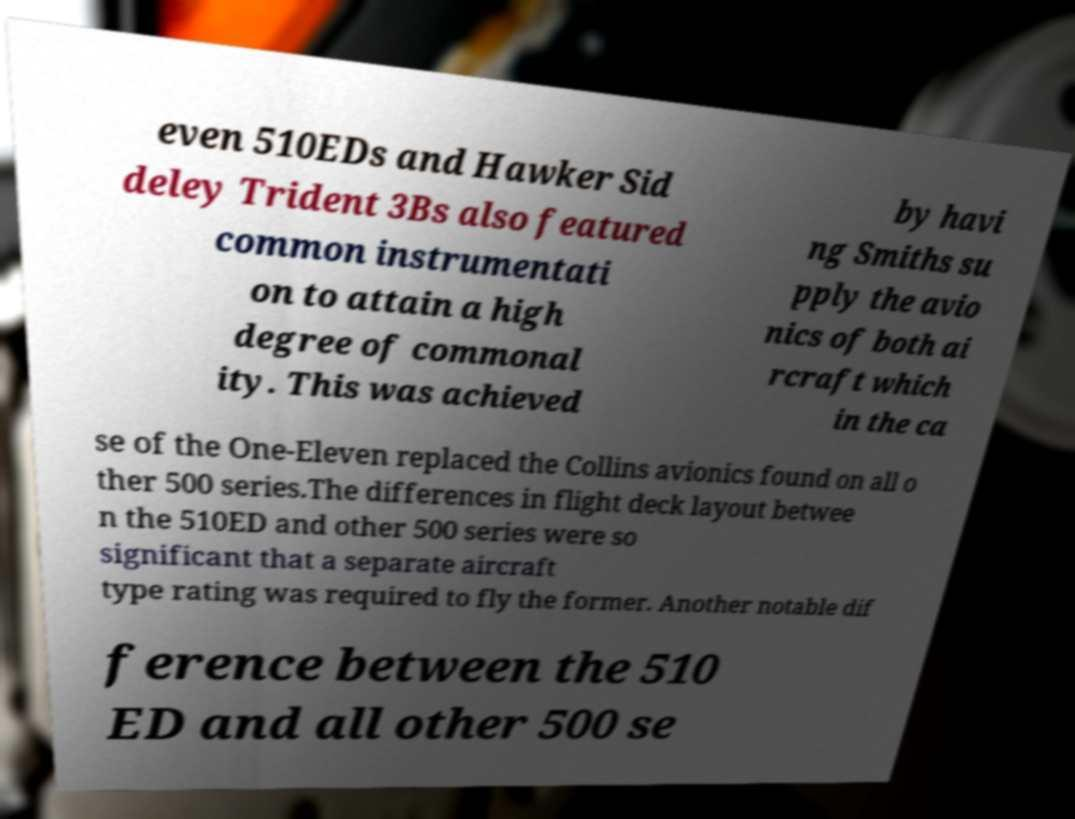There's text embedded in this image that I need extracted. Can you transcribe it verbatim? even 510EDs and Hawker Sid deley Trident 3Bs also featured common instrumentati on to attain a high degree of commonal ity. This was achieved by havi ng Smiths su pply the avio nics of both ai rcraft which in the ca se of the One-Eleven replaced the Collins avionics found on all o ther 500 series.The differences in flight deck layout betwee n the 510ED and other 500 series were so significant that a separate aircraft type rating was required to fly the former. Another notable dif ference between the 510 ED and all other 500 se 